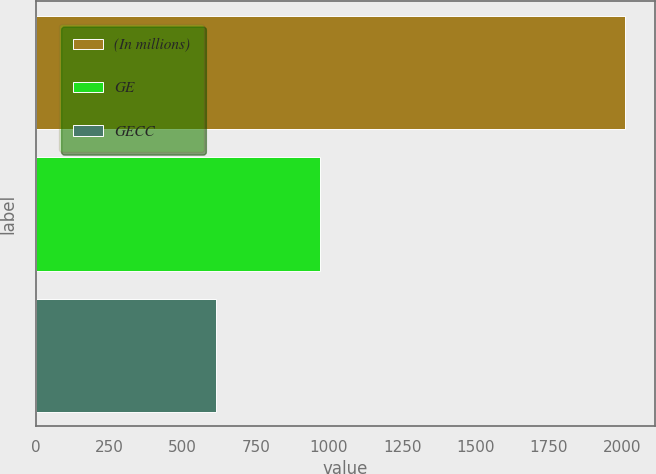Convert chart. <chart><loc_0><loc_0><loc_500><loc_500><bar_chart><fcel>(In millions)<fcel>GE<fcel>GECC<nl><fcel>2011<fcel>968<fcel>615<nl></chart> 